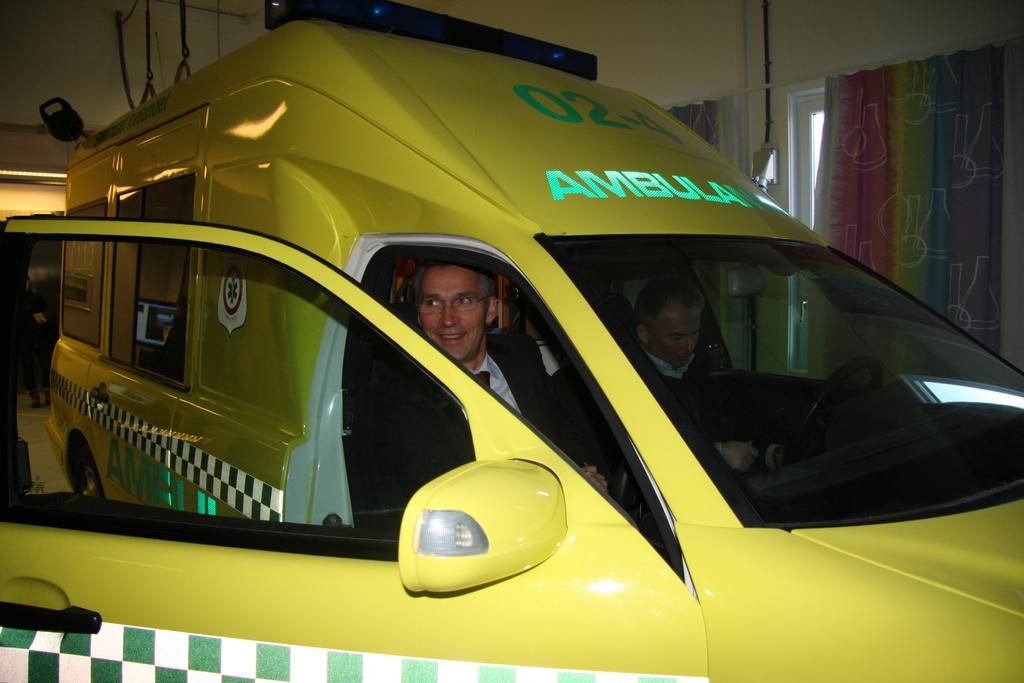<image>
Relay a brief, clear account of the picture shown. Ambulance number 02-4 sits parked with it's door open. 